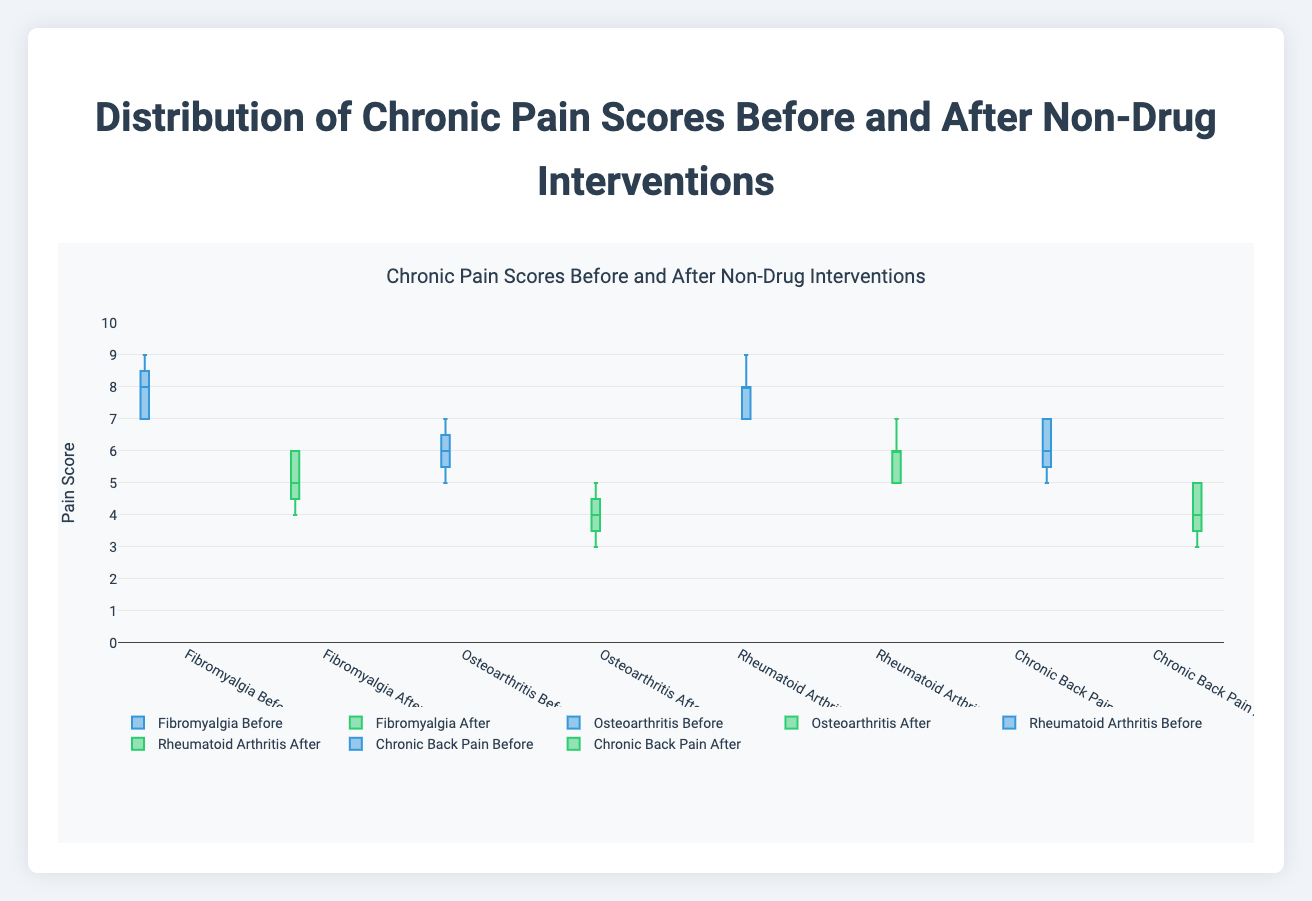What is the title of the plot? The title is displayed at the top of the plot, and it summarizes the content of the plot by describing the distribution of chronic pain scores before and after non-drug interventions.
Answer: Distribution of Chronic Pain Scores Before and After Non-Drug Interventions What is the range of the y-axis? The y-axis of the plot measures pain scores, and the range can be determined by examining the lowest and highest values on the y-axis. In this plot, it extends from 0 to 10, as specified in the axis settings.
Answer: 0 to 10 How does the median pain score for chronic back pain before intervention compare to after intervention? To find the median pain scores, we look at the line inside each box plot. For chronic back pain, the median before intervention is higher than after intervention.
Answer: Higher before intervention Which patient group experienced the largest reduction in median pain score after the intervention? By comparing the median lines of the before and after box plots for each patient group, Fibromyalgia shows the largest reduction in the middle line's position.
Answer: Fibromyalgia What is the interquartile range (IQR) of chronic back pain scores after the intervention? The IQR is the difference between the upper and lower quartiles (Q3-Q1). For chronic back pain after intervention, the box extends from Q1=3.5 to Q3=5, giving an IQR of 5 - 3.5 = 1.5.
Answer: 1.5 What are the minimum and maximum pain scores for Osteoarthritis after the intervention? The minimum and maximum values are denoted by the ends of the whiskers. For Osteoarthritis after intervention, min=3 and max=5.
Answer: Minimum: 3, Maximum: 5 Which group had the smallest variation in pain scores after intervention, based on the box plot widths? The smallest variation is indicated by the narrowest box plot. Osteoarthritis has the smallest box width after the intervention.
Answer: Osteoarthritis How do the pain scores for Rheumatoid Arthritis change after the intervention compared to before? By comparing the median and distribution of the box plots before and after intervention, Rheumatoid Arthritis shows a decrease in median pain score and a shift lower in the distribution.
Answer: Decrease in median and overall scores Which group's pain scores after the intervention overlap the least with their scores before the intervention? To identify the least overlap, check the separation between before and after box plots. Fibromyalgia shows the least overlap, indicating a significant change.
Answer: Fibromyalgia 